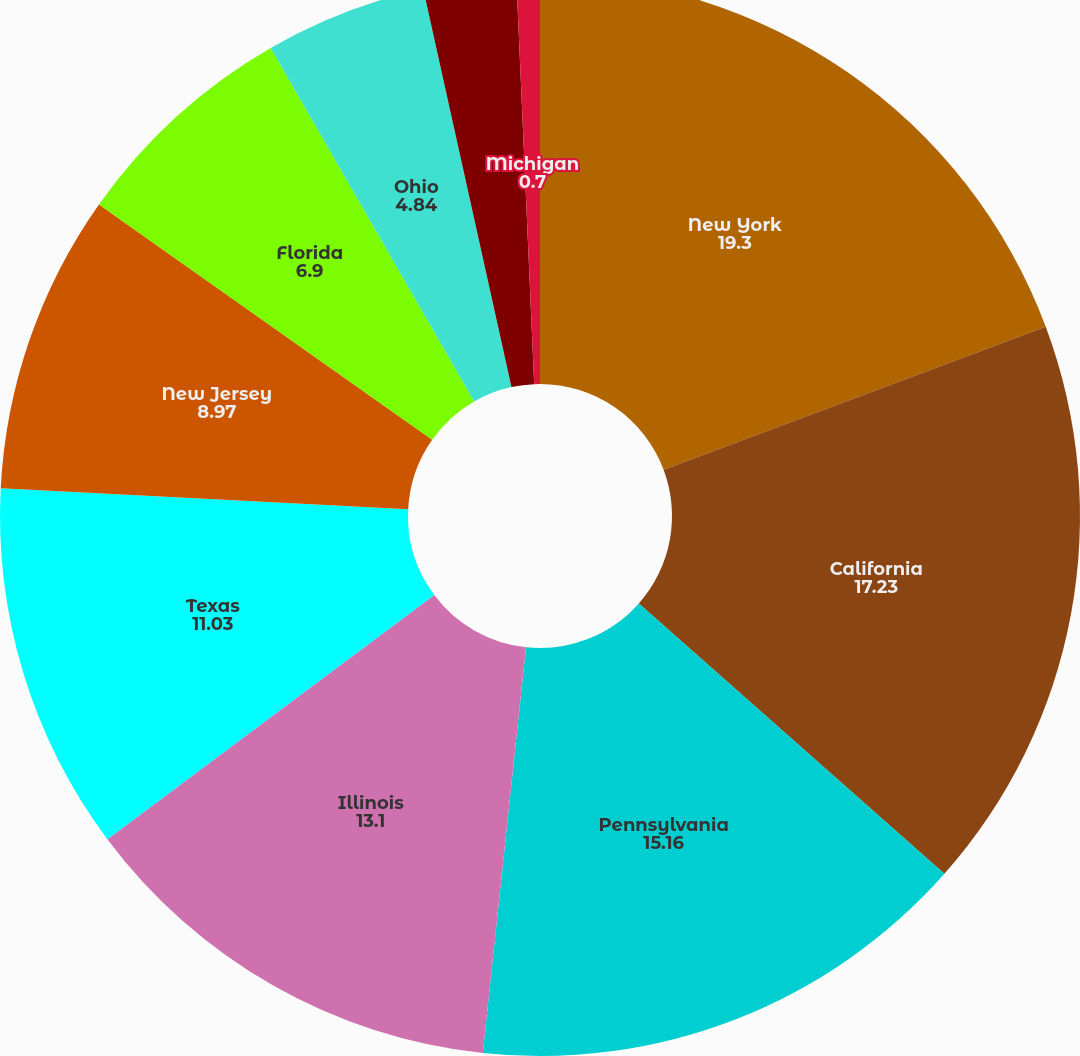Convert chart. <chart><loc_0><loc_0><loc_500><loc_500><pie_chart><fcel>New York<fcel>California<fcel>Pennsylvania<fcel>Illinois<fcel>Texas<fcel>New Jersey<fcel>Florida<fcel>Ohio<fcel>Massachusetts<fcel>Michigan<nl><fcel>19.3%<fcel>17.23%<fcel>15.16%<fcel>13.1%<fcel>11.03%<fcel>8.97%<fcel>6.9%<fcel>4.84%<fcel>2.77%<fcel>0.7%<nl></chart> 